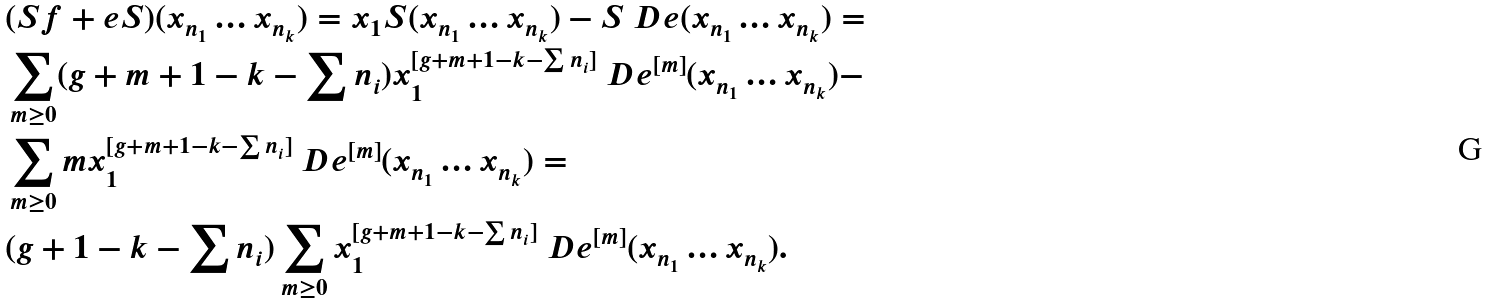<formula> <loc_0><loc_0><loc_500><loc_500>& ( S f + e S ) ( x _ { n _ { 1 } } \dots x _ { n _ { k } } ) = x _ { 1 } S ( x _ { n _ { 1 } } \dots x _ { n _ { k } } ) - S \ D e ( x _ { n _ { 1 } } \dots x _ { n _ { k } } ) = \\ & \sum _ { m \geq 0 } ( g + m + 1 - k - \sum n _ { i } ) x _ { 1 } ^ { [ g + m + 1 - k - \sum n _ { i } ] } \ D e ^ { [ m ] } ( x _ { n _ { 1 } } \dots x _ { n _ { k } } ) - \\ & \sum _ { m \geq 0 } m x _ { 1 } ^ { [ g + m + 1 - k - \sum n _ { i } ] } \ D e ^ { [ m ] } ( x _ { n _ { 1 } } \dots x _ { n _ { k } } ) = \\ & ( g + 1 - k - \sum n _ { i } ) \sum _ { m \geq 0 } x _ { 1 } ^ { [ g + m + 1 - k - \sum n _ { i } ] } \ D e ^ { [ m ] } ( x _ { n _ { 1 } } \dots x _ { n _ { k } } ) .</formula> 